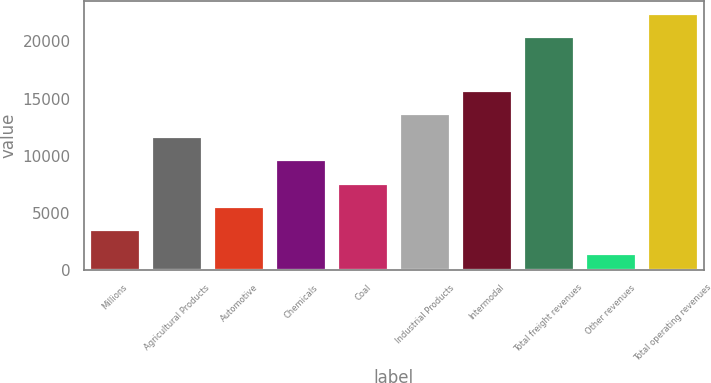<chart> <loc_0><loc_0><loc_500><loc_500><bar_chart><fcel>Millions<fcel>Agricultural Products<fcel>Automotive<fcel>Chemicals<fcel>Coal<fcel>Industrial Products<fcel>Intermodal<fcel>Total freight revenues<fcel>Other revenues<fcel>Total operating revenues<nl><fcel>3455.7<fcel>11614.5<fcel>5495.4<fcel>9574.8<fcel>7535.1<fcel>13654.2<fcel>15693.9<fcel>20397<fcel>1416<fcel>22436.7<nl></chart> 